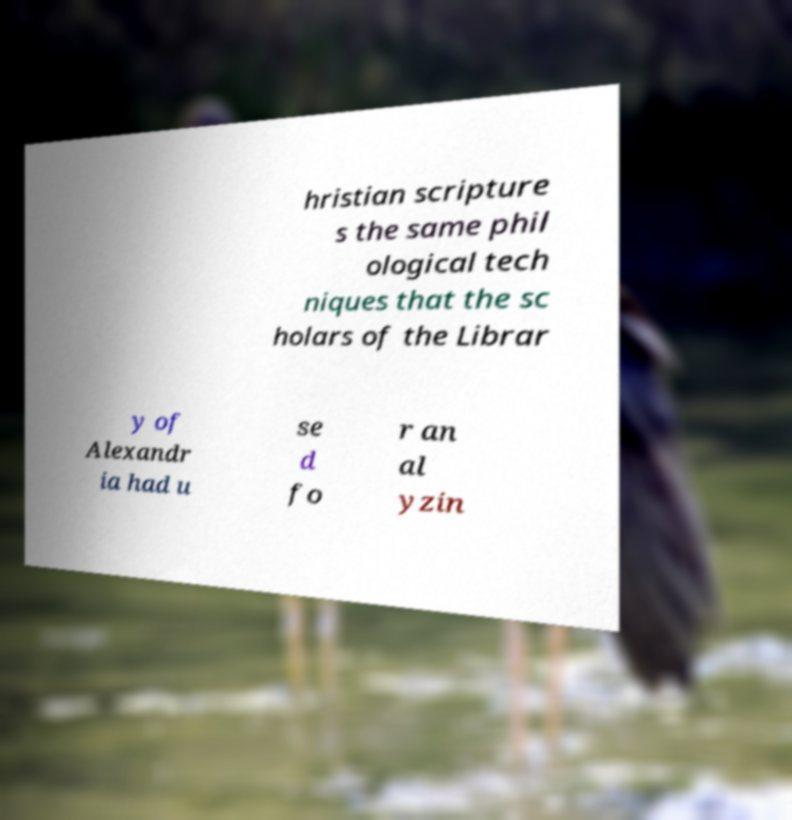Please identify and transcribe the text found in this image. hristian scripture s the same phil ological tech niques that the sc holars of the Librar y of Alexandr ia had u se d fo r an al yzin 